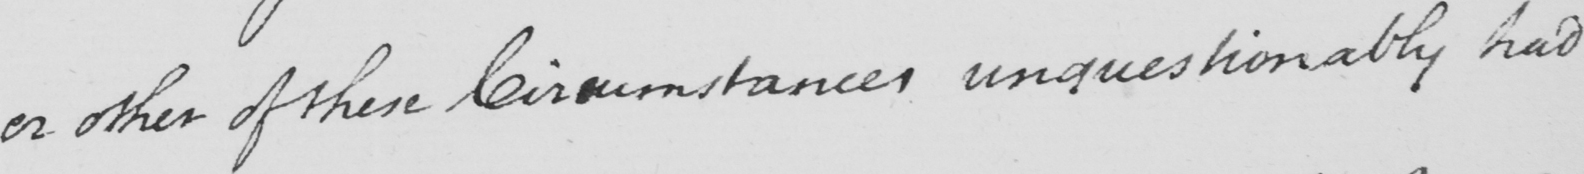Can you read and transcribe this handwriting? or other of these Circumstances unquestionably had 